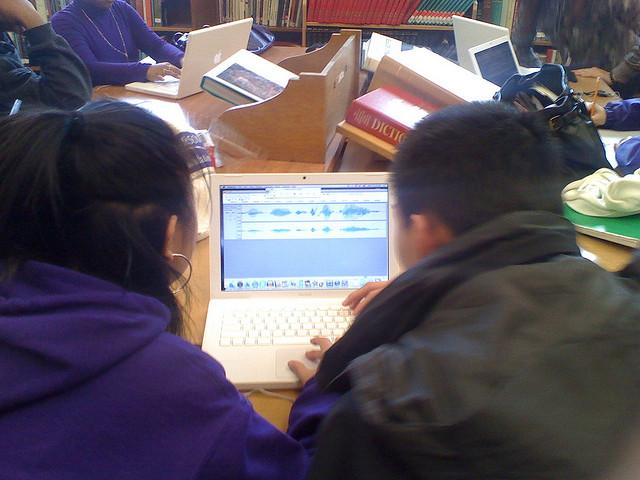Without the computers where would they look up definitions? Please explain your reasoning. red book. The people would use the red book. 